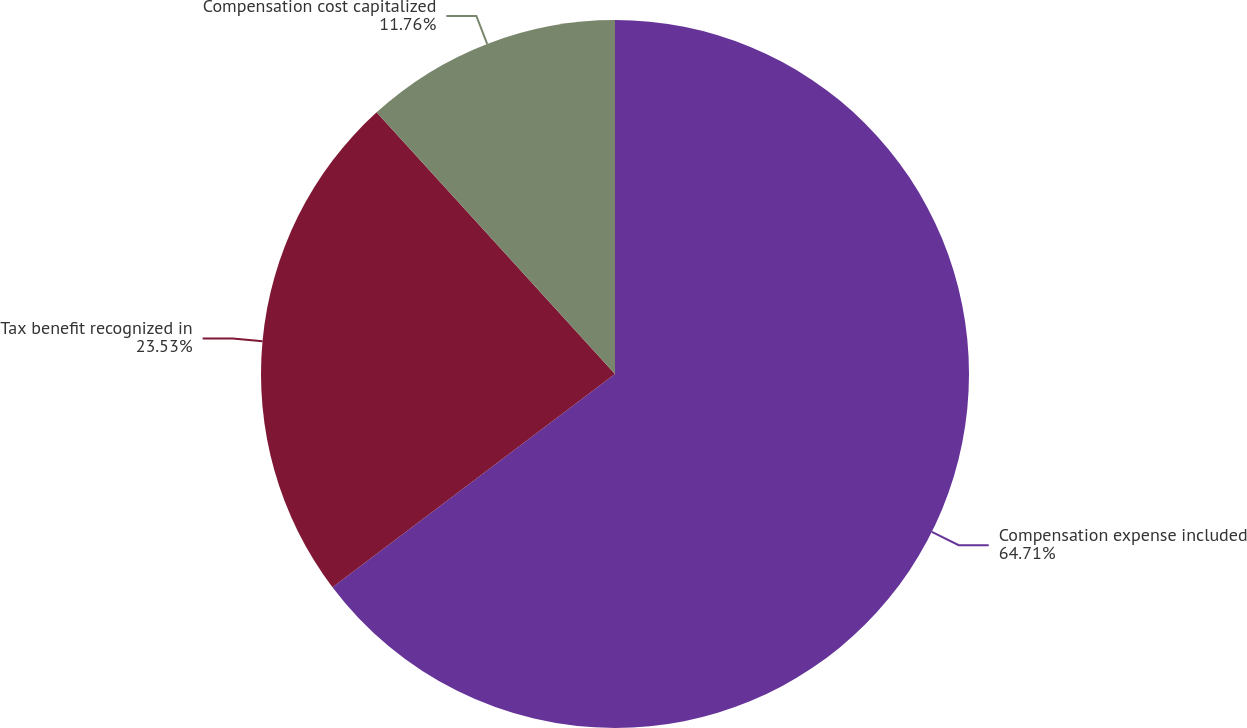<chart> <loc_0><loc_0><loc_500><loc_500><pie_chart><fcel>Compensation expense included<fcel>Tax benefit recognized in<fcel>Compensation cost capitalized<nl><fcel>64.71%<fcel>23.53%<fcel>11.76%<nl></chart> 